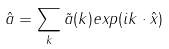Convert formula to latex. <formula><loc_0><loc_0><loc_500><loc_500>\hat { a } = \sum _ { k } \tilde { a } ( k ) e x p ( i k \cdot \hat { x } )</formula> 